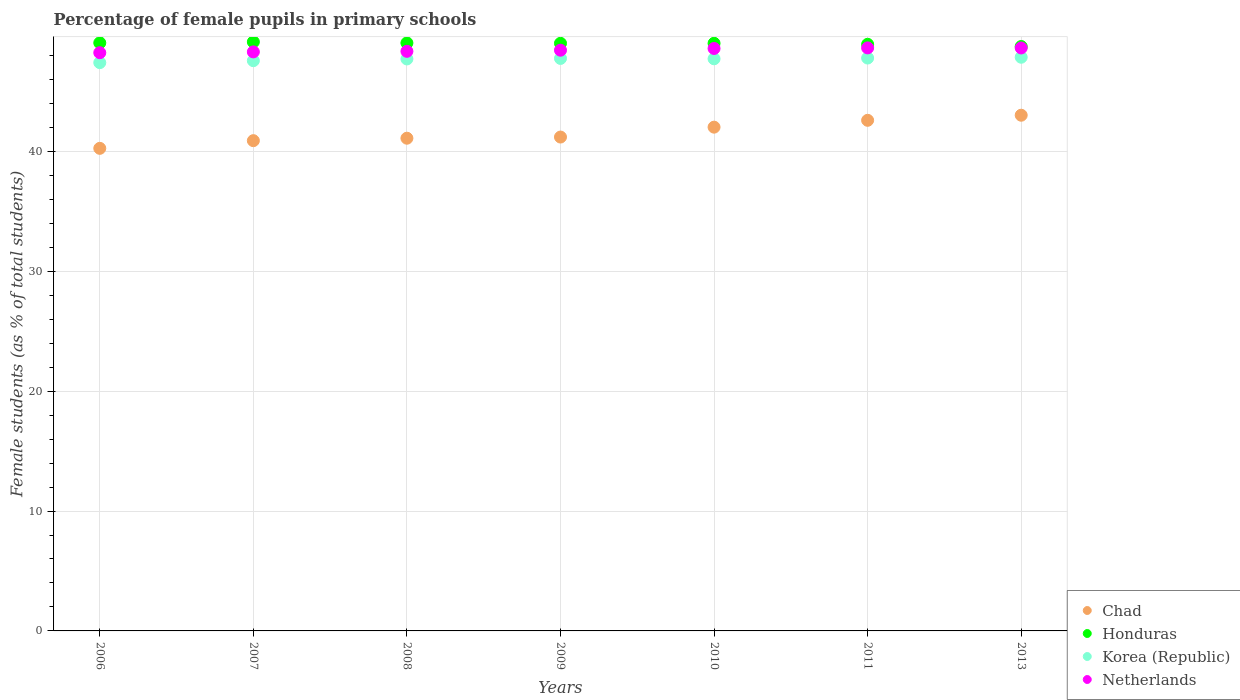How many different coloured dotlines are there?
Ensure brevity in your answer.  4. What is the percentage of female pupils in primary schools in Honduras in 2008?
Your answer should be compact. 49.04. Across all years, what is the maximum percentage of female pupils in primary schools in Korea (Republic)?
Offer a terse response. 47.85. Across all years, what is the minimum percentage of female pupils in primary schools in Honduras?
Provide a succinct answer. 48.74. What is the total percentage of female pupils in primary schools in Chad in the graph?
Your answer should be very brief. 291.04. What is the difference between the percentage of female pupils in primary schools in Korea (Republic) in 2006 and that in 2013?
Your answer should be very brief. -0.45. What is the difference between the percentage of female pupils in primary schools in Honduras in 2011 and the percentage of female pupils in primary schools in Chad in 2009?
Your answer should be compact. 7.74. What is the average percentage of female pupils in primary schools in Korea (Republic) per year?
Offer a terse response. 47.68. In the year 2011, what is the difference between the percentage of female pupils in primary schools in Korea (Republic) and percentage of female pupils in primary schools in Netherlands?
Provide a short and direct response. -0.85. In how many years, is the percentage of female pupils in primary schools in Honduras greater than 40 %?
Give a very brief answer. 7. What is the ratio of the percentage of female pupils in primary schools in Chad in 2009 to that in 2010?
Give a very brief answer. 0.98. Is the percentage of female pupils in primary schools in Netherlands in 2006 less than that in 2007?
Keep it short and to the point. Yes. Is the difference between the percentage of female pupils in primary schools in Korea (Republic) in 2006 and 2009 greater than the difference between the percentage of female pupils in primary schools in Netherlands in 2006 and 2009?
Provide a short and direct response. No. What is the difference between the highest and the second highest percentage of female pupils in primary schools in Netherlands?
Give a very brief answer. 0.01. What is the difference between the highest and the lowest percentage of female pupils in primary schools in Korea (Republic)?
Your response must be concise. 0.45. Is it the case that in every year, the sum of the percentage of female pupils in primary schools in Netherlands and percentage of female pupils in primary schools in Chad  is greater than the sum of percentage of female pupils in primary schools in Honduras and percentage of female pupils in primary schools in Korea (Republic)?
Ensure brevity in your answer.  No. Is it the case that in every year, the sum of the percentage of female pupils in primary schools in Netherlands and percentage of female pupils in primary schools in Chad  is greater than the percentage of female pupils in primary schools in Honduras?
Make the answer very short. Yes. Is the percentage of female pupils in primary schools in Honduras strictly greater than the percentage of female pupils in primary schools in Chad over the years?
Your answer should be compact. Yes. Is the percentage of female pupils in primary schools in Netherlands strictly less than the percentage of female pupils in primary schools in Honduras over the years?
Your answer should be compact. Yes. How many dotlines are there?
Make the answer very short. 4. How many years are there in the graph?
Make the answer very short. 7. What is the difference between two consecutive major ticks on the Y-axis?
Your response must be concise. 10. Are the values on the major ticks of Y-axis written in scientific E-notation?
Give a very brief answer. No. What is the title of the graph?
Your answer should be very brief. Percentage of female pupils in primary schools. What is the label or title of the Y-axis?
Make the answer very short. Female students (as % of total students). What is the Female students (as % of total students) of Chad in 2006?
Your answer should be compact. 40.25. What is the Female students (as % of total students) in Honduras in 2006?
Your response must be concise. 49.05. What is the Female students (as % of total students) in Korea (Republic) in 2006?
Ensure brevity in your answer.  47.4. What is the Female students (as % of total students) in Netherlands in 2006?
Offer a very short reply. 48.23. What is the Female students (as % of total students) of Chad in 2007?
Offer a terse response. 40.89. What is the Female students (as % of total students) of Honduras in 2007?
Your answer should be compact. 49.13. What is the Female students (as % of total students) of Korea (Republic) in 2007?
Provide a short and direct response. 47.56. What is the Female students (as % of total students) in Netherlands in 2007?
Offer a terse response. 48.29. What is the Female students (as % of total students) of Chad in 2008?
Offer a terse response. 41.09. What is the Female students (as % of total students) of Honduras in 2008?
Your answer should be very brief. 49.04. What is the Female students (as % of total students) in Korea (Republic) in 2008?
Give a very brief answer. 47.71. What is the Female students (as % of total students) in Netherlands in 2008?
Your answer should be compact. 48.34. What is the Female students (as % of total students) in Chad in 2009?
Your answer should be very brief. 41.19. What is the Female students (as % of total students) in Honduras in 2009?
Give a very brief answer. 49.01. What is the Female students (as % of total students) of Korea (Republic) in 2009?
Your answer should be very brief. 47.75. What is the Female students (as % of total students) in Netherlands in 2009?
Your answer should be compact. 48.43. What is the Female students (as % of total students) in Chad in 2010?
Give a very brief answer. 42.02. What is the Female students (as % of total students) of Honduras in 2010?
Make the answer very short. 49.01. What is the Female students (as % of total students) in Korea (Republic) in 2010?
Your answer should be very brief. 47.72. What is the Female students (as % of total students) in Netherlands in 2010?
Provide a short and direct response. 48.58. What is the Female students (as % of total students) in Chad in 2011?
Ensure brevity in your answer.  42.59. What is the Female students (as % of total students) in Honduras in 2011?
Ensure brevity in your answer.  48.93. What is the Female students (as % of total students) of Korea (Republic) in 2011?
Your response must be concise. 47.78. What is the Female students (as % of total students) in Netherlands in 2011?
Make the answer very short. 48.63. What is the Female students (as % of total students) of Chad in 2013?
Offer a terse response. 43.01. What is the Female students (as % of total students) in Honduras in 2013?
Make the answer very short. 48.74. What is the Female students (as % of total students) in Korea (Republic) in 2013?
Ensure brevity in your answer.  47.85. What is the Female students (as % of total students) of Netherlands in 2013?
Offer a terse response. 48.62. Across all years, what is the maximum Female students (as % of total students) in Chad?
Give a very brief answer. 43.01. Across all years, what is the maximum Female students (as % of total students) in Honduras?
Keep it short and to the point. 49.13. Across all years, what is the maximum Female students (as % of total students) in Korea (Republic)?
Keep it short and to the point. 47.85. Across all years, what is the maximum Female students (as % of total students) of Netherlands?
Make the answer very short. 48.63. Across all years, what is the minimum Female students (as % of total students) in Chad?
Your answer should be compact. 40.25. Across all years, what is the minimum Female students (as % of total students) in Honduras?
Offer a very short reply. 48.74. Across all years, what is the minimum Female students (as % of total students) in Korea (Republic)?
Your response must be concise. 47.4. Across all years, what is the minimum Female students (as % of total students) in Netherlands?
Offer a terse response. 48.23. What is the total Female students (as % of total students) of Chad in the graph?
Your answer should be compact. 291.04. What is the total Female students (as % of total students) of Honduras in the graph?
Your answer should be very brief. 342.91. What is the total Female students (as % of total students) of Korea (Republic) in the graph?
Provide a succinct answer. 333.76. What is the total Female students (as % of total students) in Netherlands in the graph?
Your response must be concise. 339.12. What is the difference between the Female students (as % of total students) of Chad in 2006 and that in 2007?
Your answer should be very brief. -0.64. What is the difference between the Female students (as % of total students) of Honduras in 2006 and that in 2007?
Your answer should be compact. -0.08. What is the difference between the Female students (as % of total students) in Korea (Republic) in 2006 and that in 2007?
Give a very brief answer. -0.16. What is the difference between the Female students (as % of total students) of Netherlands in 2006 and that in 2007?
Your answer should be very brief. -0.07. What is the difference between the Female students (as % of total students) in Chad in 2006 and that in 2008?
Make the answer very short. -0.84. What is the difference between the Female students (as % of total students) in Honduras in 2006 and that in 2008?
Offer a very short reply. 0.01. What is the difference between the Female students (as % of total students) in Korea (Republic) in 2006 and that in 2008?
Keep it short and to the point. -0.31. What is the difference between the Female students (as % of total students) in Netherlands in 2006 and that in 2008?
Provide a succinct answer. -0.11. What is the difference between the Female students (as % of total students) of Chad in 2006 and that in 2009?
Offer a terse response. -0.94. What is the difference between the Female students (as % of total students) in Honduras in 2006 and that in 2009?
Your answer should be compact. 0.04. What is the difference between the Female students (as % of total students) of Korea (Republic) in 2006 and that in 2009?
Ensure brevity in your answer.  -0.35. What is the difference between the Female students (as % of total students) of Netherlands in 2006 and that in 2009?
Offer a terse response. -0.21. What is the difference between the Female students (as % of total students) in Chad in 2006 and that in 2010?
Your response must be concise. -1.77. What is the difference between the Female students (as % of total students) in Honduras in 2006 and that in 2010?
Offer a very short reply. 0.04. What is the difference between the Female students (as % of total students) in Korea (Republic) in 2006 and that in 2010?
Your answer should be compact. -0.32. What is the difference between the Female students (as % of total students) of Netherlands in 2006 and that in 2010?
Provide a succinct answer. -0.35. What is the difference between the Female students (as % of total students) of Chad in 2006 and that in 2011?
Ensure brevity in your answer.  -2.34. What is the difference between the Female students (as % of total students) of Honduras in 2006 and that in 2011?
Give a very brief answer. 0.12. What is the difference between the Female students (as % of total students) in Korea (Republic) in 2006 and that in 2011?
Your response must be concise. -0.38. What is the difference between the Female students (as % of total students) in Netherlands in 2006 and that in 2011?
Provide a succinct answer. -0.4. What is the difference between the Female students (as % of total students) of Chad in 2006 and that in 2013?
Offer a very short reply. -2.76. What is the difference between the Female students (as % of total students) in Honduras in 2006 and that in 2013?
Make the answer very short. 0.31. What is the difference between the Female students (as % of total students) in Korea (Republic) in 2006 and that in 2013?
Offer a terse response. -0.45. What is the difference between the Female students (as % of total students) of Netherlands in 2006 and that in 2013?
Offer a very short reply. -0.39. What is the difference between the Female students (as % of total students) in Chad in 2007 and that in 2008?
Your answer should be compact. -0.2. What is the difference between the Female students (as % of total students) of Honduras in 2007 and that in 2008?
Ensure brevity in your answer.  0.09. What is the difference between the Female students (as % of total students) of Korea (Republic) in 2007 and that in 2008?
Offer a terse response. -0.14. What is the difference between the Female students (as % of total students) of Netherlands in 2007 and that in 2008?
Make the answer very short. -0.05. What is the difference between the Female students (as % of total students) in Chad in 2007 and that in 2009?
Your answer should be very brief. -0.3. What is the difference between the Female students (as % of total students) of Honduras in 2007 and that in 2009?
Ensure brevity in your answer.  0.12. What is the difference between the Female students (as % of total students) of Korea (Republic) in 2007 and that in 2009?
Offer a very short reply. -0.19. What is the difference between the Female students (as % of total students) in Netherlands in 2007 and that in 2009?
Make the answer very short. -0.14. What is the difference between the Female students (as % of total students) in Chad in 2007 and that in 2010?
Keep it short and to the point. -1.13. What is the difference between the Female students (as % of total students) of Honduras in 2007 and that in 2010?
Offer a terse response. 0.12. What is the difference between the Female students (as % of total students) of Korea (Republic) in 2007 and that in 2010?
Provide a short and direct response. -0.16. What is the difference between the Female students (as % of total students) in Netherlands in 2007 and that in 2010?
Provide a succinct answer. -0.28. What is the difference between the Female students (as % of total students) of Chad in 2007 and that in 2011?
Keep it short and to the point. -1.7. What is the difference between the Female students (as % of total students) of Honduras in 2007 and that in 2011?
Ensure brevity in your answer.  0.2. What is the difference between the Female students (as % of total students) of Korea (Republic) in 2007 and that in 2011?
Your response must be concise. -0.22. What is the difference between the Female students (as % of total students) in Chad in 2007 and that in 2013?
Make the answer very short. -2.12. What is the difference between the Female students (as % of total students) of Honduras in 2007 and that in 2013?
Your answer should be very brief. 0.38. What is the difference between the Female students (as % of total students) of Korea (Republic) in 2007 and that in 2013?
Your response must be concise. -0.29. What is the difference between the Female students (as % of total students) of Netherlands in 2007 and that in 2013?
Give a very brief answer. -0.33. What is the difference between the Female students (as % of total students) of Chad in 2008 and that in 2009?
Ensure brevity in your answer.  -0.1. What is the difference between the Female students (as % of total students) in Honduras in 2008 and that in 2009?
Provide a short and direct response. 0.03. What is the difference between the Female students (as % of total students) of Korea (Republic) in 2008 and that in 2009?
Provide a succinct answer. -0.04. What is the difference between the Female students (as % of total students) in Netherlands in 2008 and that in 2009?
Give a very brief answer. -0.09. What is the difference between the Female students (as % of total students) of Chad in 2008 and that in 2010?
Offer a terse response. -0.92. What is the difference between the Female students (as % of total students) in Honduras in 2008 and that in 2010?
Offer a terse response. 0.03. What is the difference between the Female students (as % of total students) in Korea (Republic) in 2008 and that in 2010?
Make the answer very short. -0.01. What is the difference between the Female students (as % of total students) in Netherlands in 2008 and that in 2010?
Your response must be concise. -0.24. What is the difference between the Female students (as % of total students) in Chad in 2008 and that in 2011?
Ensure brevity in your answer.  -1.49. What is the difference between the Female students (as % of total students) of Honduras in 2008 and that in 2011?
Your response must be concise. 0.11. What is the difference between the Female students (as % of total students) in Korea (Republic) in 2008 and that in 2011?
Give a very brief answer. -0.08. What is the difference between the Female students (as % of total students) in Netherlands in 2008 and that in 2011?
Your response must be concise. -0.29. What is the difference between the Female students (as % of total students) of Chad in 2008 and that in 2013?
Offer a terse response. -1.92. What is the difference between the Female students (as % of total students) in Honduras in 2008 and that in 2013?
Make the answer very short. 0.3. What is the difference between the Female students (as % of total students) of Korea (Republic) in 2008 and that in 2013?
Keep it short and to the point. -0.14. What is the difference between the Female students (as % of total students) of Netherlands in 2008 and that in 2013?
Offer a very short reply. -0.28. What is the difference between the Female students (as % of total students) of Chad in 2009 and that in 2010?
Provide a succinct answer. -0.83. What is the difference between the Female students (as % of total students) in Honduras in 2009 and that in 2010?
Offer a very short reply. -0. What is the difference between the Female students (as % of total students) of Korea (Republic) in 2009 and that in 2010?
Your answer should be compact. 0.03. What is the difference between the Female students (as % of total students) in Netherlands in 2009 and that in 2010?
Provide a short and direct response. -0.14. What is the difference between the Female students (as % of total students) of Chad in 2009 and that in 2011?
Your response must be concise. -1.4. What is the difference between the Female students (as % of total students) in Honduras in 2009 and that in 2011?
Ensure brevity in your answer.  0.08. What is the difference between the Female students (as % of total students) in Korea (Republic) in 2009 and that in 2011?
Your response must be concise. -0.03. What is the difference between the Female students (as % of total students) in Netherlands in 2009 and that in 2011?
Make the answer very short. -0.19. What is the difference between the Female students (as % of total students) in Chad in 2009 and that in 2013?
Ensure brevity in your answer.  -1.82. What is the difference between the Female students (as % of total students) in Honduras in 2009 and that in 2013?
Your response must be concise. 0.27. What is the difference between the Female students (as % of total students) of Korea (Republic) in 2009 and that in 2013?
Give a very brief answer. -0.1. What is the difference between the Female students (as % of total students) of Netherlands in 2009 and that in 2013?
Give a very brief answer. -0.19. What is the difference between the Female students (as % of total students) in Chad in 2010 and that in 2011?
Provide a short and direct response. -0.57. What is the difference between the Female students (as % of total students) of Honduras in 2010 and that in 2011?
Provide a succinct answer. 0.08. What is the difference between the Female students (as % of total students) in Korea (Republic) in 2010 and that in 2011?
Make the answer very short. -0.06. What is the difference between the Female students (as % of total students) in Netherlands in 2010 and that in 2011?
Ensure brevity in your answer.  -0.05. What is the difference between the Female students (as % of total students) of Chad in 2010 and that in 2013?
Offer a very short reply. -1. What is the difference between the Female students (as % of total students) in Honduras in 2010 and that in 2013?
Your response must be concise. 0.27. What is the difference between the Female students (as % of total students) of Korea (Republic) in 2010 and that in 2013?
Provide a short and direct response. -0.13. What is the difference between the Female students (as % of total students) of Netherlands in 2010 and that in 2013?
Your answer should be compact. -0.04. What is the difference between the Female students (as % of total students) in Chad in 2011 and that in 2013?
Make the answer very short. -0.42. What is the difference between the Female students (as % of total students) in Honduras in 2011 and that in 2013?
Ensure brevity in your answer.  0.18. What is the difference between the Female students (as % of total students) in Korea (Republic) in 2011 and that in 2013?
Your answer should be compact. -0.07. What is the difference between the Female students (as % of total students) of Netherlands in 2011 and that in 2013?
Provide a short and direct response. 0.01. What is the difference between the Female students (as % of total students) of Chad in 2006 and the Female students (as % of total students) of Honduras in 2007?
Provide a succinct answer. -8.88. What is the difference between the Female students (as % of total students) of Chad in 2006 and the Female students (as % of total students) of Korea (Republic) in 2007?
Your answer should be very brief. -7.31. What is the difference between the Female students (as % of total students) of Chad in 2006 and the Female students (as % of total students) of Netherlands in 2007?
Offer a very short reply. -8.04. What is the difference between the Female students (as % of total students) in Honduras in 2006 and the Female students (as % of total students) in Korea (Republic) in 2007?
Your answer should be compact. 1.49. What is the difference between the Female students (as % of total students) of Honduras in 2006 and the Female students (as % of total students) of Netherlands in 2007?
Keep it short and to the point. 0.75. What is the difference between the Female students (as % of total students) in Korea (Republic) in 2006 and the Female students (as % of total students) in Netherlands in 2007?
Offer a very short reply. -0.9. What is the difference between the Female students (as % of total students) of Chad in 2006 and the Female students (as % of total students) of Honduras in 2008?
Provide a short and direct response. -8.79. What is the difference between the Female students (as % of total students) of Chad in 2006 and the Female students (as % of total students) of Korea (Republic) in 2008?
Your response must be concise. -7.46. What is the difference between the Female students (as % of total students) of Chad in 2006 and the Female students (as % of total students) of Netherlands in 2008?
Offer a terse response. -8.09. What is the difference between the Female students (as % of total students) of Honduras in 2006 and the Female students (as % of total students) of Korea (Republic) in 2008?
Ensure brevity in your answer.  1.34. What is the difference between the Female students (as % of total students) of Honduras in 2006 and the Female students (as % of total students) of Netherlands in 2008?
Provide a short and direct response. 0.71. What is the difference between the Female students (as % of total students) in Korea (Republic) in 2006 and the Female students (as % of total students) in Netherlands in 2008?
Your response must be concise. -0.94. What is the difference between the Female students (as % of total students) in Chad in 2006 and the Female students (as % of total students) in Honduras in 2009?
Give a very brief answer. -8.76. What is the difference between the Female students (as % of total students) of Chad in 2006 and the Female students (as % of total students) of Korea (Republic) in 2009?
Offer a very short reply. -7.5. What is the difference between the Female students (as % of total students) of Chad in 2006 and the Female students (as % of total students) of Netherlands in 2009?
Keep it short and to the point. -8.19. What is the difference between the Female students (as % of total students) in Honduras in 2006 and the Female students (as % of total students) in Korea (Republic) in 2009?
Offer a terse response. 1.3. What is the difference between the Female students (as % of total students) in Honduras in 2006 and the Female students (as % of total students) in Netherlands in 2009?
Make the answer very short. 0.61. What is the difference between the Female students (as % of total students) in Korea (Republic) in 2006 and the Female students (as % of total students) in Netherlands in 2009?
Give a very brief answer. -1.04. What is the difference between the Female students (as % of total students) of Chad in 2006 and the Female students (as % of total students) of Honduras in 2010?
Ensure brevity in your answer.  -8.76. What is the difference between the Female students (as % of total students) of Chad in 2006 and the Female students (as % of total students) of Korea (Republic) in 2010?
Your answer should be very brief. -7.47. What is the difference between the Female students (as % of total students) of Chad in 2006 and the Female students (as % of total students) of Netherlands in 2010?
Provide a succinct answer. -8.33. What is the difference between the Female students (as % of total students) of Honduras in 2006 and the Female students (as % of total students) of Korea (Republic) in 2010?
Make the answer very short. 1.33. What is the difference between the Female students (as % of total students) in Honduras in 2006 and the Female students (as % of total students) in Netherlands in 2010?
Keep it short and to the point. 0.47. What is the difference between the Female students (as % of total students) of Korea (Republic) in 2006 and the Female students (as % of total students) of Netherlands in 2010?
Your answer should be compact. -1.18. What is the difference between the Female students (as % of total students) of Chad in 2006 and the Female students (as % of total students) of Honduras in 2011?
Make the answer very short. -8.68. What is the difference between the Female students (as % of total students) in Chad in 2006 and the Female students (as % of total students) in Korea (Republic) in 2011?
Provide a succinct answer. -7.53. What is the difference between the Female students (as % of total students) of Chad in 2006 and the Female students (as % of total students) of Netherlands in 2011?
Provide a short and direct response. -8.38. What is the difference between the Female students (as % of total students) in Honduras in 2006 and the Female students (as % of total students) in Korea (Republic) in 2011?
Provide a short and direct response. 1.27. What is the difference between the Female students (as % of total students) in Honduras in 2006 and the Female students (as % of total students) in Netherlands in 2011?
Your answer should be very brief. 0.42. What is the difference between the Female students (as % of total students) in Korea (Republic) in 2006 and the Female students (as % of total students) in Netherlands in 2011?
Your response must be concise. -1.23. What is the difference between the Female students (as % of total students) in Chad in 2006 and the Female students (as % of total students) in Honduras in 2013?
Give a very brief answer. -8.49. What is the difference between the Female students (as % of total students) in Chad in 2006 and the Female students (as % of total students) in Korea (Republic) in 2013?
Offer a very short reply. -7.6. What is the difference between the Female students (as % of total students) in Chad in 2006 and the Female students (as % of total students) in Netherlands in 2013?
Keep it short and to the point. -8.37. What is the difference between the Female students (as % of total students) in Honduras in 2006 and the Female students (as % of total students) in Korea (Republic) in 2013?
Offer a very short reply. 1.2. What is the difference between the Female students (as % of total students) in Honduras in 2006 and the Female students (as % of total students) in Netherlands in 2013?
Ensure brevity in your answer.  0.43. What is the difference between the Female students (as % of total students) in Korea (Republic) in 2006 and the Female students (as % of total students) in Netherlands in 2013?
Make the answer very short. -1.22. What is the difference between the Female students (as % of total students) of Chad in 2007 and the Female students (as % of total students) of Honduras in 2008?
Make the answer very short. -8.15. What is the difference between the Female students (as % of total students) in Chad in 2007 and the Female students (as % of total students) in Korea (Republic) in 2008?
Provide a succinct answer. -6.82. What is the difference between the Female students (as % of total students) of Chad in 2007 and the Female students (as % of total students) of Netherlands in 2008?
Keep it short and to the point. -7.45. What is the difference between the Female students (as % of total students) of Honduras in 2007 and the Female students (as % of total students) of Korea (Republic) in 2008?
Offer a very short reply. 1.42. What is the difference between the Female students (as % of total students) in Honduras in 2007 and the Female students (as % of total students) in Netherlands in 2008?
Give a very brief answer. 0.79. What is the difference between the Female students (as % of total students) in Korea (Republic) in 2007 and the Female students (as % of total students) in Netherlands in 2008?
Offer a terse response. -0.78. What is the difference between the Female students (as % of total students) in Chad in 2007 and the Female students (as % of total students) in Honduras in 2009?
Ensure brevity in your answer.  -8.12. What is the difference between the Female students (as % of total students) of Chad in 2007 and the Female students (as % of total students) of Korea (Republic) in 2009?
Give a very brief answer. -6.86. What is the difference between the Female students (as % of total students) in Chad in 2007 and the Female students (as % of total students) in Netherlands in 2009?
Ensure brevity in your answer.  -7.54. What is the difference between the Female students (as % of total students) of Honduras in 2007 and the Female students (as % of total students) of Korea (Republic) in 2009?
Offer a very short reply. 1.38. What is the difference between the Female students (as % of total students) of Honduras in 2007 and the Female students (as % of total students) of Netherlands in 2009?
Give a very brief answer. 0.69. What is the difference between the Female students (as % of total students) in Korea (Republic) in 2007 and the Female students (as % of total students) in Netherlands in 2009?
Your answer should be compact. -0.87. What is the difference between the Female students (as % of total students) in Chad in 2007 and the Female students (as % of total students) in Honduras in 2010?
Your answer should be compact. -8.12. What is the difference between the Female students (as % of total students) in Chad in 2007 and the Female students (as % of total students) in Korea (Republic) in 2010?
Keep it short and to the point. -6.83. What is the difference between the Female students (as % of total students) in Chad in 2007 and the Female students (as % of total students) in Netherlands in 2010?
Provide a succinct answer. -7.69. What is the difference between the Female students (as % of total students) of Honduras in 2007 and the Female students (as % of total students) of Korea (Republic) in 2010?
Your response must be concise. 1.41. What is the difference between the Female students (as % of total students) of Honduras in 2007 and the Female students (as % of total students) of Netherlands in 2010?
Your response must be concise. 0.55. What is the difference between the Female students (as % of total students) of Korea (Republic) in 2007 and the Female students (as % of total students) of Netherlands in 2010?
Make the answer very short. -1.02. What is the difference between the Female students (as % of total students) in Chad in 2007 and the Female students (as % of total students) in Honduras in 2011?
Your response must be concise. -8.04. What is the difference between the Female students (as % of total students) of Chad in 2007 and the Female students (as % of total students) of Korea (Republic) in 2011?
Give a very brief answer. -6.89. What is the difference between the Female students (as % of total students) of Chad in 2007 and the Female students (as % of total students) of Netherlands in 2011?
Your response must be concise. -7.74. What is the difference between the Female students (as % of total students) in Honduras in 2007 and the Female students (as % of total students) in Korea (Republic) in 2011?
Provide a succinct answer. 1.35. What is the difference between the Female students (as % of total students) in Honduras in 2007 and the Female students (as % of total students) in Netherlands in 2011?
Provide a short and direct response. 0.5. What is the difference between the Female students (as % of total students) of Korea (Republic) in 2007 and the Female students (as % of total students) of Netherlands in 2011?
Your answer should be very brief. -1.07. What is the difference between the Female students (as % of total students) in Chad in 2007 and the Female students (as % of total students) in Honduras in 2013?
Your response must be concise. -7.85. What is the difference between the Female students (as % of total students) in Chad in 2007 and the Female students (as % of total students) in Korea (Republic) in 2013?
Provide a succinct answer. -6.96. What is the difference between the Female students (as % of total students) of Chad in 2007 and the Female students (as % of total students) of Netherlands in 2013?
Give a very brief answer. -7.73. What is the difference between the Female students (as % of total students) in Honduras in 2007 and the Female students (as % of total students) in Korea (Republic) in 2013?
Give a very brief answer. 1.28. What is the difference between the Female students (as % of total students) of Honduras in 2007 and the Female students (as % of total students) of Netherlands in 2013?
Provide a short and direct response. 0.51. What is the difference between the Female students (as % of total students) in Korea (Republic) in 2007 and the Female students (as % of total students) in Netherlands in 2013?
Your answer should be compact. -1.06. What is the difference between the Female students (as % of total students) in Chad in 2008 and the Female students (as % of total students) in Honduras in 2009?
Provide a short and direct response. -7.92. What is the difference between the Female students (as % of total students) of Chad in 2008 and the Female students (as % of total students) of Korea (Republic) in 2009?
Provide a short and direct response. -6.65. What is the difference between the Female students (as % of total students) of Chad in 2008 and the Female students (as % of total students) of Netherlands in 2009?
Give a very brief answer. -7.34. What is the difference between the Female students (as % of total students) in Honduras in 2008 and the Female students (as % of total students) in Korea (Republic) in 2009?
Give a very brief answer. 1.29. What is the difference between the Female students (as % of total students) of Honduras in 2008 and the Female students (as % of total students) of Netherlands in 2009?
Your answer should be very brief. 0.6. What is the difference between the Female students (as % of total students) of Korea (Republic) in 2008 and the Female students (as % of total students) of Netherlands in 2009?
Make the answer very short. -0.73. What is the difference between the Female students (as % of total students) of Chad in 2008 and the Female students (as % of total students) of Honduras in 2010?
Offer a terse response. -7.92. What is the difference between the Female students (as % of total students) in Chad in 2008 and the Female students (as % of total students) in Korea (Republic) in 2010?
Your response must be concise. -6.62. What is the difference between the Female students (as % of total students) of Chad in 2008 and the Female students (as % of total students) of Netherlands in 2010?
Provide a succinct answer. -7.48. What is the difference between the Female students (as % of total students) in Honduras in 2008 and the Female students (as % of total students) in Korea (Republic) in 2010?
Keep it short and to the point. 1.32. What is the difference between the Female students (as % of total students) in Honduras in 2008 and the Female students (as % of total students) in Netherlands in 2010?
Provide a short and direct response. 0.46. What is the difference between the Female students (as % of total students) in Korea (Republic) in 2008 and the Female students (as % of total students) in Netherlands in 2010?
Provide a short and direct response. -0.87. What is the difference between the Female students (as % of total students) in Chad in 2008 and the Female students (as % of total students) in Honduras in 2011?
Provide a short and direct response. -7.83. What is the difference between the Female students (as % of total students) in Chad in 2008 and the Female students (as % of total students) in Korea (Republic) in 2011?
Give a very brief answer. -6.69. What is the difference between the Female students (as % of total students) of Chad in 2008 and the Female students (as % of total students) of Netherlands in 2011?
Keep it short and to the point. -7.53. What is the difference between the Female students (as % of total students) in Honduras in 2008 and the Female students (as % of total students) in Korea (Republic) in 2011?
Offer a terse response. 1.26. What is the difference between the Female students (as % of total students) of Honduras in 2008 and the Female students (as % of total students) of Netherlands in 2011?
Provide a succinct answer. 0.41. What is the difference between the Female students (as % of total students) of Korea (Republic) in 2008 and the Female students (as % of total students) of Netherlands in 2011?
Your response must be concise. -0.92. What is the difference between the Female students (as % of total students) in Chad in 2008 and the Female students (as % of total students) in Honduras in 2013?
Make the answer very short. -7.65. What is the difference between the Female students (as % of total students) of Chad in 2008 and the Female students (as % of total students) of Korea (Republic) in 2013?
Provide a short and direct response. -6.75. What is the difference between the Female students (as % of total students) in Chad in 2008 and the Female students (as % of total students) in Netherlands in 2013?
Make the answer very short. -7.53. What is the difference between the Female students (as % of total students) of Honduras in 2008 and the Female students (as % of total students) of Korea (Republic) in 2013?
Your answer should be compact. 1.19. What is the difference between the Female students (as % of total students) in Honduras in 2008 and the Female students (as % of total students) in Netherlands in 2013?
Your response must be concise. 0.42. What is the difference between the Female students (as % of total students) of Korea (Republic) in 2008 and the Female students (as % of total students) of Netherlands in 2013?
Provide a short and direct response. -0.92. What is the difference between the Female students (as % of total students) in Chad in 2009 and the Female students (as % of total students) in Honduras in 2010?
Keep it short and to the point. -7.82. What is the difference between the Female students (as % of total students) of Chad in 2009 and the Female students (as % of total students) of Korea (Republic) in 2010?
Give a very brief answer. -6.53. What is the difference between the Female students (as % of total students) in Chad in 2009 and the Female students (as % of total students) in Netherlands in 2010?
Keep it short and to the point. -7.39. What is the difference between the Female students (as % of total students) of Honduras in 2009 and the Female students (as % of total students) of Korea (Republic) in 2010?
Keep it short and to the point. 1.29. What is the difference between the Female students (as % of total students) in Honduras in 2009 and the Female students (as % of total students) in Netherlands in 2010?
Your answer should be compact. 0.43. What is the difference between the Female students (as % of total students) in Korea (Republic) in 2009 and the Female students (as % of total students) in Netherlands in 2010?
Ensure brevity in your answer.  -0.83. What is the difference between the Female students (as % of total students) of Chad in 2009 and the Female students (as % of total students) of Honduras in 2011?
Provide a short and direct response. -7.74. What is the difference between the Female students (as % of total students) in Chad in 2009 and the Female students (as % of total students) in Korea (Republic) in 2011?
Offer a terse response. -6.59. What is the difference between the Female students (as % of total students) of Chad in 2009 and the Female students (as % of total students) of Netherlands in 2011?
Ensure brevity in your answer.  -7.44. What is the difference between the Female students (as % of total students) of Honduras in 2009 and the Female students (as % of total students) of Korea (Republic) in 2011?
Provide a succinct answer. 1.23. What is the difference between the Female students (as % of total students) in Honduras in 2009 and the Female students (as % of total students) in Netherlands in 2011?
Your answer should be compact. 0.38. What is the difference between the Female students (as % of total students) of Korea (Republic) in 2009 and the Female students (as % of total students) of Netherlands in 2011?
Offer a very short reply. -0.88. What is the difference between the Female students (as % of total students) in Chad in 2009 and the Female students (as % of total students) in Honduras in 2013?
Provide a succinct answer. -7.55. What is the difference between the Female students (as % of total students) in Chad in 2009 and the Female students (as % of total students) in Korea (Republic) in 2013?
Your answer should be very brief. -6.66. What is the difference between the Female students (as % of total students) of Chad in 2009 and the Female students (as % of total students) of Netherlands in 2013?
Your response must be concise. -7.43. What is the difference between the Female students (as % of total students) of Honduras in 2009 and the Female students (as % of total students) of Korea (Republic) in 2013?
Make the answer very short. 1.16. What is the difference between the Female students (as % of total students) of Honduras in 2009 and the Female students (as % of total students) of Netherlands in 2013?
Give a very brief answer. 0.39. What is the difference between the Female students (as % of total students) of Korea (Republic) in 2009 and the Female students (as % of total students) of Netherlands in 2013?
Your answer should be compact. -0.87. What is the difference between the Female students (as % of total students) in Chad in 2010 and the Female students (as % of total students) in Honduras in 2011?
Offer a very short reply. -6.91. What is the difference between the Female students (as % of total students) in Chad in 2010 and the Female students (as % of total students) in Korea (Republic) in 2011?
Your response must be concise. -5.77. What is the difference between the Female students (as % of total students) of Chad in 2010 and the Female students (as % of total students) of Netherlands in 2011?
Provide a short and direct response. -6.61. What is the difference between the Female students (as % of total students) in Honduras in 2010 and the Female students (as % of total students) in Korea (Republic) in 2011?
Make the answer very short. 1.23. What is the difference between the Female students (as % of total students) in Honduras in 2010 and the Female students (as % of total students) in Netherlands in 2011?
Make the answer very short. 0.38. What is the difference between the Female students (as % of total students) of Korea (Republic) in 2010 and the Female students (as % of total students) of Netherlands in 2011?
Provide a succinct answer. -0.91. What is the difference between the Female students (as % of total students) of Chad in 2010 and the Female students (as % of total students) of Honduras in 2013?
Keep it short and to the point. -6.73. What is the difference between the Female students (as % of total students) in Chad in 2010 and the Female students (as % of total students) in Korea (Republic) in 2013?
Provide a succinct answer. -5.83. What is the difference between the Female students (as % of total students) of Chad in 2010 and the Female students (as % of total students) of Netherlands in 2013?
Provide a short and direct response. -6.61. What is the difference between the Female students (as % of total students) of Honduras in 2010 and the Female students (as % of total students) of Korea (Republic) in 2013?
Your answer should be very brief. 1.16. What is the difference between the Female students (as % of total students) in Honduras in 2010 and the Female students (as % of total students) in Netherlands in 2013?
Offer a terse response. 0.39. What is the difference between the Female students (as % of total students) of Korea (Republic) in 2010 and the Female students (as % of total students) of Netherlands in 2013?
Ensure brevity in your answer.  -0.9. What is the difference between the Female students (as % of total students) in Chad in 2011 and the Female students (as % of total students) in Honduras in 2013?
Give a very brief answer. -6.16. What is the difference between the Female students (as % of total students) in Chad in 2011 and the Female students (as % of total students) in Korea (Republic) in 2013?
Your answer should be compact. -5.26. What is the difference between the Female students (as % of total students) of Chad in 2011 and the Female students (as % of total students) of Netherlands in 2013?
Offer a very short reply. -6.03. What is the difference between the Female students (as % of total students) in Honduras in 2011 and the Female students (as % of total students) in Korea (Republic) in 2013?
Provide a succinct answer. 1.08. What is the difference between the Female students (as % of total students) in Honduras in 2011 and the Female students (as % of total students) in Netherlands in 2013?
Your answer should be very brief. 0.31. What is the difference between the Female students (as % of total students) of Korea (Republic) in 2011 and the Female students (as % of total students) of Netherlands in 2013?
Your response must be concise. -0.84. What is the average Female students (as % of total students) in Chad per year?
Your response must be concise. 41.58. What is the average Female students (as % of total students) of Honduras per year?
Ensure brevity in your answer.  48.99. What is the average Female students (as % of total students) of Korea (Republic) per year?
Offer a terse response. 47.68. What is the average Female students (as % of total students) in Netherlands per year?
Keep it short and to the point. 48.45. In the year 2006, what is the difference between the Female students (as % of total students) in Chad and Female students (as % of total students) in Honduras?
Your response must be concise. -8.8. In the year 2006, what is the difference between the Female students (as % of total students) in Chad and Female students (as % of total students) in Korea (Republic)?
Your answer should be compact. -7.15. In the year 2006, what is the difference between the Female students (as % of total students) of Chad and Female students (as % of total students) of Netherlands?
Provide a succinct answer. -7.98. In the year 2006, what is the difference between the Female students (as % of total students) of Honduras and Female students (as % of total students) of Korea (Republic)?
Offer a very short reply. 1.65. In the year 2006, what is the difference between the Female students (as % of total students) of Honduras and Female students (as % of total students) of Netherlands?
Keep it short and to the point. 0.82. In the year 2006, what is the difference between the Female students (as % of total students) in Korea (Republic) and Female students (as % of total students) in Netherlands?
Make the answer very short. -0.83. In the year 2007, what is the difference between the Female students (as % of total students) in Chad and Female students (as % of total students) in Honduras?
Keep it short and to the point. -8.24. In the year 2007, what is the difference between the Female students (as % of total students) in Chad and Female students (as % of total students) in Korea (Republic)?
Your answer should be compact. -6.67. In the year 2007, what is the difference between the Female students (as % of total students) in Chad and Female students (as % of total students) in Netherlands?
Your answer should be very brief. -7.4. In the year 2007, what is the difference between the Female students (as % of total students) of Honduras and Female students (as % of total students) of Korea (Republic)?
Offer a terse response. 1.57. In the year 2007, what is the difference between the Female students (as % of total students) of Honduras and Female students (as % of total students) of Netherlands?
Provide a succinct answer. 0.83. In the year 2007, what is the difference between the Female students (as % of total students) of Korea (Republic) and Female students (as % of total students) of Netherlands?
Make the answer very short. -0.73. In the year 2008, what is the difference between the Female students (as % of total students) in Chad and Female students (as % of total students) in Honduras?
Offer a terse response. -7.94. In the year 2008, what is the difference between the Female students (as % of total students) of Chad and Female students (as % of total students) of Korea (Republic)?
Ensure brevity in your answer.  -6.61. In the year 2008, what is the difference between the Female students (as % of total students) in Chad and Female students (as % of total students) in Netherlands?
Offer a terse response. -7.25. In the year 2008, what is the difference between the Female students (as % of total students) in Honduras and Female students (as % of total students) in Netherlands?
Provide a succinct answer. 0.7. In the year 2008, what is the difference between the Female students (as % of total students) of Korea (Republic) and Female students (as % of total students) of Netherlands?
Offer a very short reply. -0.64. In the year 2009, what is the difference between the Female students (as % of total students) in Chad and Female students (as % of total students) in Honduras?
Make the answer very short. -7.82. In the year 2009, what is the difference between the Female students (as % of total students) in Chad and Female students (as % of total students) in Korea (Republic)?
Keep it short and to the point. -6.56. In the year 2009, what is the difference between the Female students (as % of total students) in Chad and Female students (as % of total students) in Netherlands?
Ensure brevity in your answer.  -7.24. In the year 2009, what is the difference between the Female students (as % of total students) of Honduras and Female students (as % of total students) of Korea (Republic)?
Give a very brief answer. 1.26. In the year 2009, what is the difference between the Female students (as % of total students) of Honduras and Female students (as % of total students) of Netherlands?
Your response must be concise. 0.58. In the year 2009, what is the difference between the Female students (as % of total students) of Korea (Republic) and Female students (as % of total students) of Netherlands?
Give a very brief answer. -0.69. In the year 2010, what is the difference between the Female students (as % of total students) in Chad and Female students (as % of total students) in Honduras?
Ensure brevity in your answer.  -7. In the year 2010, what is the difference between the Female students (as % of total students) in Chad and Female students (as % of total students) in Korea (Republic)?
Your answer should be very brief. -5.7. In the year 2010, what is the difference between the Female students (as % of total students) in Chad and Female students (as % of total students) in Netherlands?
Provide a short and direct response. -6.56. In the year 2010, what is the difference between the Female students (as % of total students) of Honduras and Female students (as % of total students) of Korea (Republic)?
Your response must be concise. 1.29. In the year 2010, what is the difference between the Female students (as % of total students) of Honduras and Female students (as % of total students) of Netherlands?
Keep it short and to the point. 0.43. In the year 2010, what is the difference between the Female students (as % of total students) in Korea (Republic) and Female students (as % of total students) in Netherlands?
Offer a terse response. -0.86. In the year 2011, what is the difference between the Female students (as % of total students) of Chad and Female students (as % of total students) of Honduras?
Ensure brevity in your answer.  -6.34. In the year 2011, what is the difference between the Female students (as % of total students) in Chad and Female students (as % of total students) in Korea (Republic)?
Offer a terse response. -5.19. In the year 2011, what is the difference between the Female students (as % of total students) of Chad and Female students (as % of total students) of Netherlands?
Your answer should be compact. -6.04. In the year 2011, what is the difference between the Female students (as % of total students) of Honduras and Female students (as % of total students) of Korea (Republic)?
Give a very brief answer. 1.15. In the year 2011, what is the difference between the Female students (as % of total students) in Honduras and Female students (as % of total students) in Netherlands?
Ensure brevity in your answer.  0.3. In the year 2011, what is the difference between the Female students (as % of total students) of Korea (Republic) and Female students (as % of total students) of Netherlands?
Provide a succinct answer. -0.85. In the year 2013, what is the difference between the Female students (as % of total students) in Chad and Female students (as % of total students) in Honduras?
Your answer should be very brief. -5.73. In the year 2013, what is the difference between the Female students (as % of total students) of Chad and Female students (as % of total students) of Korea (Republic)?
Keep it short and to the point. -4.84. In the year 2013, what is the difference between the Female students (as % of total students) of Chad and Female students (as % of total students) of Netherlands?
Your answer should be very brief. -5.61. In the year 2013, what is the difference between the Female students (as % of total students) in Honduras and Female students (as % of total students) in Korea (Republic)?
Provide a succinct answer. 0.9. In the year 2013, what is the difference between the Female students (as % of total students) in Honduras and Female students (as % of total students) in Netherlands?
Ensure brevity in your answer.  0.12. In the year 2013, what is the difference between the Female students (as % of total students) in Korea (Republic) and Female students (as % of total students) in Netherlands?
Provide a short and direct response. -0.77. What is the ratio of the Female students (as % of total students) in Chad in 2006 to that in 2007?
Your response must be concise. 0.98. What is the ratio of the Female students (as % of total students) in Chad in 2006 to that in 2008?
Keep it short and to the point. 0.98. What is the ratio of the Female students (as % of total students) in Honduras in 2006 to that in 2008?
Keep it short and to the point. 1. What is the ratio of the Female students (as % of total students) in Netherlands in 2006 to that in 2008?
Make the answer very short. 1. What is the ratio of the Female students (as % of total students) of Chad in 2006 to that in 2009?
Provide a succinct answer. 0.98. What is the ratio of the Female students (as % of total students) of Chad in 2006 to that in 2010?
Give a very brief answer. 0.96. What is the ratio of the Female students (as % of total students) of Korea (Republic) in 2006 to that in 2010?
Make the answer very short. 0.99. What is the ratio of the Female students (as % of total students) of Netherlands in 2006 to that in 2010?
Provide a succinct answer. 0.99. What is the ratio of the Female students (as % of total students) in Chad in 2006 to that in 2011?
Your response must be concise. 0.95. What is the ratio of the Female students (as % of total students) of Korea (Republic) in 2006 to that in 2011?
Offer a very short reply. 0.99. What is the ratio of the Female students (as % of total students) of Netherlands in 2006 to that in 2011?
Ensure brevity in your answer.  0.99. What is the ratio of the Female students (as % of total students) in Chad in 2006 to that in 2013?
Give a very brief answer. 0.94. What is the ratio of the Female students (as % of total students) of Honduras in 2006 to that in 2013?
Give a very brief answer. 1.01. What is the ratio of the Female students (as % of total students) in Korea (Republic) in 2006 to that in 2013?
Give a very brief answer. 0.99. What is the ratio of the Female students (as % of total students) in Honduras in 2007 to that in 2008?
Give a very brief answer. 1. What is the ratio of the Female students (as % of total students) of Chad in 2007 to that in 2009?
Provide a short and direct response. 0.99. What is the ratio of the Female students (as % of total students) of Netherlands in 2007 to that in 2009?
Your answer should be compact. 1. What is the ratio of the Female students (as % of total students) in Chad in 2007 to that in 2010?
Offer a terse response. 0.97. What is the ratio of the Female students (as % of total students) in Netherlands in 2007 to that in 2010?
Your response must be concise. 0.99. What is the ratio of the Female students (as % of total students) of Chad in 2007 to that in 2011?
Offer a very short reply. 0.96. What is the ratio of the Female students (as % of total students) in Honduras in 2007 to that in 2011?
Offer a very short reply. 1. What is the ratio of the Female students (as % of total students) in Korea (Republic) in 2007 to that in 2011?
Provide a succinct answer. 1. What is the ratio of the Female students (as % of total students) of Netherlands in 2007 to that in 2011?
Offer a very short reply. 0.99. What is the ratio of the Female students (as % of total students) in Chad in 2007 to that in 2013?
Keep it short and to the point. 0.95. What is the ratio of the Female students (as % of total students) in Honduras in 2007 to that in 2013?
Your response must be concise. 1.01. What is the ratio of the Female students (as % of total students) in Korea (Republic) in 2007 to that in 2013?
Make the answer very short. 0.99. What is the ratio of the Female students (as % of total students) of Netherlands in 2007 to that in 2013?
Provide a succinct answer. 0.99. What is the ratio of the Female students (as % of total students) of Chad in 2008 to that in 2009?
Keep it short and to the point. 1. What is the ratio of the Female students (as % of total students) in Honduras in 2008 to that in 2009?
Give a very brief answer. 1. What is the ratio of the Female students (as % of total students) in Honduras in 2008 to that in 2010?
Give a very brief answer. 1. What is the ratio of the Female students (as % of total students) in Korea (Republic) in 2008 to that in 2010?
Offer a very short reply. 1. What is the ratio of the Female students (as % of total students) of Chad in 2008 to that in 2011?
Give a very brief answer. 0.96. What is the ratio of the Female students (as % of total students) in Honduras in 2008 to that in 2011?
Provide a succinct answer. 1. What is the ratio of the Female students (as % of total students) of Korea (Republic) in 2008 to that in 2011?
Give a very brief answer. 1. What is the ratio of the Female students (as % of total students) of Netherlands in 2008 to that in 2011?
Your answer should be compact. 0.99. What is the ratio of the Female students (as % of total students) of Chad in 2008 to that in 2013?
Make the answer very short. 0.96. What is the ratio of the Female students (as % of total students) of Korea (Republic) in 2008 to that in 2013?
Your answer should be compact. 1. What is the ratio of the Female students (as % of total students) of Netherlands in 2008 to that in 2013?
Your response must be concise. 0.99. What is the ratio of the Female students (as % of total students) in Chad in 2009 to that in 2010?
Your answer should be very brief. 0.98. What is the ratio of the Female students (as % of total students) in Korea (Republic) in 2009 to that in 2010?
Provide a short and direct response. 1. What is the ratio of the Female students (as % of total students) of Chad in 2009 to that in 2011?
Ensure brevity in your answer.  0.97. What is the ratio of the Female students (as % of total students) of Honduras in 2009 to that in 2011?
Provide a succinct answer. 1. What is the ratio of the Female students (as % of total students) in Chad in 2009 to that in 2013?
Your answer should be compact. 0.96. What is the ratio of the Female students (as % of total students) of Honduras in 2009 to that in 2013?
Offer a terse response. 1.01. What is the ratio of the Female students (as % of total students) of Chad in 2010 to that in 2011?
Provide a short and direct response. 0.99. What is the ratio of the Female students (as % of total students) of Honduras in 2010 to that in 2011?
Your answer should be very brief. 1. What is the ratio of the Female students (as % of total students) of Korea (Republic) in 2010 to that in 2011?
Your answer should be very brief. 1. What is the ratio of the Female students (as % of total students) in Chad in 2010 to that in 2013?
Your response must be concise. 0.98. What is the ratio of the Female students (as % of total students) in Honduras in 2010 to that in 2013?
Provide a short and direct response. 1.01. What is the ratio of the Female students (as % of total students) in Korea (Republic) in 2011 to that in 2013?
Provide a succinct answer. 1. What is the difference between the highest and the second highest Female students (as % of total students) of Chad?
Your answer should be very brief. 0.42. What is the difference between the highest and the second highest Female students (as % of total students) in Honduras?
Give a very brief answer. 0.08. What is the difference between the highest and the second highest Female students (as % of total students) of Korea (Republic)?
Offer a terse response. 0.07. What is the difference between the highest and the second highest Female students (as % of total students) of Netherlands?
Provide a succinct answer. 0.01. What is the difference between the highest and the lowest Female students (as % of total students) in Chad?
Offer a terse response. 2.76. What is the difference between the highest and the lowest Female students (as % of total students) in Honduras?
Provide a short and direct response. 0.38. What is the difference between the highest and the lowest Female students (as % of total students) of Korea (Republic)?
Give a very brief answer. 0.45. 